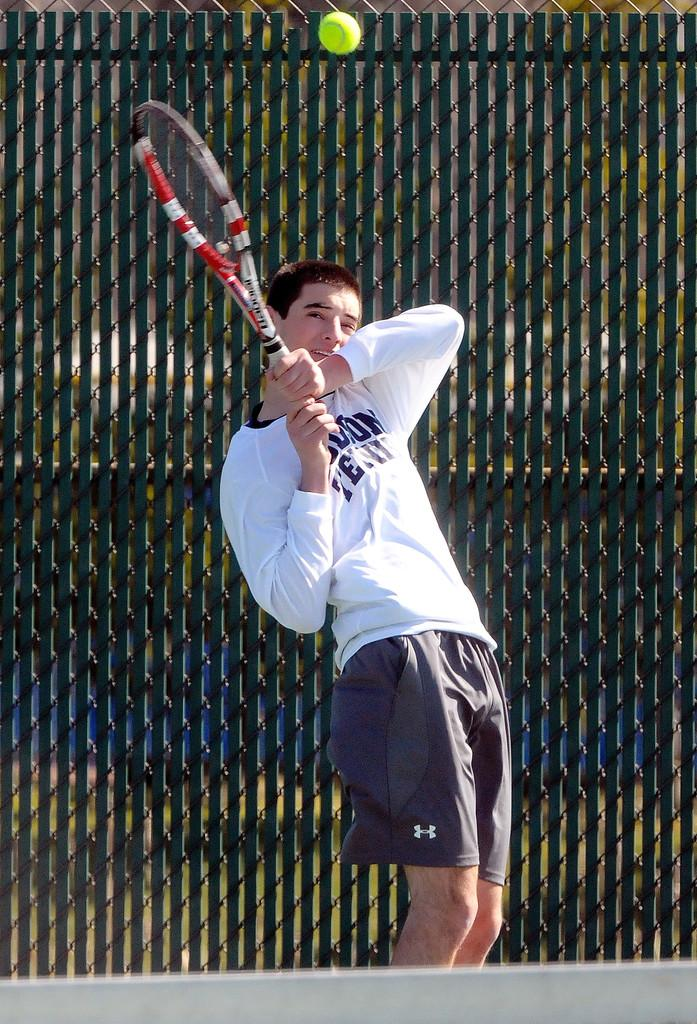Who is present in the image? There is a man in the image. What is the man holding in the image? The man is holding a tennis racket. What color is the ball in the image? There is a green color ball in the image. What can be seen in the background of the image? There is a fence in the background of the image. Can you tell me how many bubbles are floating around the man in the image? There are no bubbles present in the image. What type of muscle is the man flexing in the image? The image does not show the man flexing any muscles. 